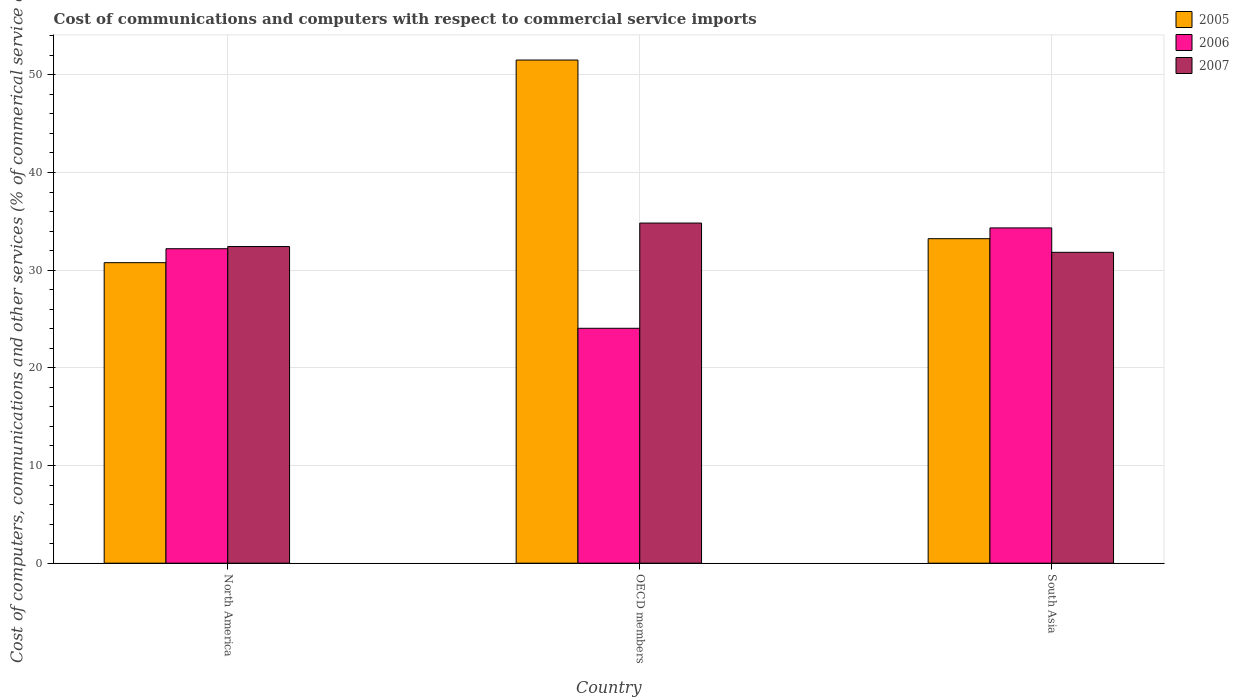How many different coloured bars are there?
Provide a short and direct response. 3. How many groups of bars are there?
Offer a terse response. 3. Are the number of bars per tick equal to the number of legend labels?
Ensure brevity in your answer.  Yes. What is the label of the 3rd group of bars from the left?
Provide a short and direct response. South Asia. What is the cost of communications and computers in 2005 in OECD members?
Your response must be concise. 51.51. Across all countries, what is the maximum cost of communications and computers in 2007?
Offer a terse response. 34.82. Across all countries, what is the minimum cost of communications and computers in 2007?
Offer a terse response. 31.83. What is the total cost of communications and computers in 2007 in the graph?
Provide a short and direct response. 99.07. What is the difference between the cost of communications and computers in 2006 in North America and that in South Asia?
Give a very brief answer. -2.13. What is the difference between the cost of communications and computers in 2007 in OECD members and the cost of communications and computers in 2006 in North America?
Make the answer very short. 2.63. What is the average cost of communications and computers in 2007 per country?
Provide a succinct answer. 33.02. What is the difference between the cost of communications and computers of/in 2005 and cost of communications and computers of/in 2006 in North America?
Give a very brief answer. -1.43. What is the ratio of the cost of communications and computers in 2006 in North America to that in South Asia?
Offer a very short reply. 0.94. Is the cost of communications and computers in 2007 in North America less than that in OECD members?
Offer a terse response. Yes. What is the difference between the highest and the second highest cost of communications and computers in 2005?
Ensure brevity in your answer.  -18.29. What is the difference between the highest and the lowest cost of communications and computers in 2006?
Your answer should be very brief. 10.28. In how many countries, is the cost of communications and computers in 2007 greater than the average cost of communications and computers in 2007 taken over all countries?
Keep it short and to the point. 1. What does the 1st bar from the left in OECD members represents?
Offer a terse response. 2005. Is it the case that in every country, the sum of the cost of communications and computers in 2005 and cost of communications and computers in 2006 is greater than the cost of communications and computers in 2007?
Keep it short and to the point. Yes. Are all the bars in the graph horizontal?
Ensure brevity in your answer.  No. How many countries are there in the graph?
Your response must be concise. 3. What is the difference between two consecutive major ticks on the Y-axis?
Ensure brevity in your answer.  10. Are the values on the major ticks of Y-axis written in scientific E-notation?
Offer a terse response. No. Does the graph contain grids?
Your answer should be compact. Yes. How many legend labels are there?
Offer a terse response. 3. What is the title of the graph?
Your answer should be very brief. Cost of communications and computers with respect to commercial service imports. Does "1975" appear as one of the legend labels in the graph?
Your answer should be very brief. No. What is the label or title of the X-axis?
Your answer should be very brief. Country. What is the label or title of the Y-axis?
Your answer should be very brief. Cost of computers, communications and other services (% of commerical service exports). What is the Cost of computers, communications and other services (% of commerical service exports) in 2005 in North America?
Offer a very short reply. 30.77. What is the Cost of computers, communications and other services (% of commerical service exports) in 2006 in North America?
Ensure brevity in your answer.  32.2. What is the Cost of computers, communications and other services (% of commerical service exports) in 2007 in North America?
Ensure brevity in your answer.  32.42. What is the Cost of computers, communications and other services (% of commerical service exports) of 2005 in OECD members?
Your answer should be very brief. 51.51. What is the Cost of computers, communications and other services (% of commerical service exports) in 2006 in OECD members?
Your answer should be very brief. 24.05. What is the Cost of computers, communications and other services (% of commerical service exports) of 2007 in OECD members?
Keep it short and to the point. 34.82. What is the Cost of computers, communications and other services (% of commerical service exports) in 2005 in South Asia?
Your answer should be compact. 33.22. What is the Cost of computers, communications and other services (% of commerical service exports) in 2006 in South Asia?
Ensure brevity in your answer.  34.33. What is the Cost of computers, communications and other services (% of commerical service exports) in 2007 in South Asia?
Your answer should be compact. 31.83. Across all countries, what is the maximum Cost of computers, communications and other services (% of commerical service exports) in 2005?
Offer a terse response. 51.51. Across all countries, what is the maximum Cost of computers, communications and other services (% of commerical service exports) of 2006?
Your answer should be compact. 34.33. Across all countries, what is the maximum Cost of computers, communications and other services (% of commerical service exports) in 2007?
Provide a short and direct response. 34.82. Across all countries, what is the minimum Cost of computers, communications and other services (% of commerical service exports) in 2005?
Keep it short and to the point. 30.77. Across all countries, what is the minimum Cost of computers, communications and other services (% of commerical service exports) in 2006?
Make the answer very short. 24.05. Across all countries, what is the minimum Cost of computers, communications and other services (% of commerical service exports) of 2007?
Your answer should be very brief. 31.83. What is the total Cost of computers, communications and other services (% of commerical service exports) in 2005 in the graph?
Provide a short and direct response. 115.5. What is the total Cost of computers, communications and other services (% of commerical service exports) in 2006 in the graph?
Your answer should be very brief. 90.57. What is the total Cost of computers, communications and other services (% of commerical service exports) in 2007 in the graph?
Your response must be concise. 99.07. What is the difference between the Cost of computers, communications and other services (% of commerical service exports) of 2005 in North America and that in OECD members?
Make the answer very short. -20.75. What is the difference between the Cost of computers, communications and other services (% of commerical service exports) of 2006 in North America and that in OECD members?
Give a very brief answer. 8.15. What is the difference between the Cost of computers, communications and other services (% of commerical service exports) of 2007 in North America and that in OECD members?
Your answer should be compact. -2.4. What is the difference between the Cost of computers, communications and other services (% of commerical service exports) of 2005 in North America and that in South Asia?
Your answer should be very brief. -2.46. What is the difference between the Cost of computers, communications and other services (% of commerical service exports) of 2006 in North America and that in South Asia?
Offer a terse response. -2.13. What is the difference between the Cost of computers, communications and other services (% of commerical service exports) of 2007 in North America and that in South Asia?
Give a very brief answer. 0.59. What is the difference between the Cost of computers, communications and other services (% of commerical service exports) of 2005 in OECD members and that in South Asia?
Provide a succinct answer. 18.29. What is the difference between the Cost of computers, communications and other services (% of commerical service exports) in 2006 in OECD members and that in South Asia?
Make the answer very short. -10.28. What is the difference between the Cost of computers, communications and other services (% of commerical service exports) in 2007 in OECD members and that in South Asia?
Keep it short and to the point. 3. What is the difference between the Cost of computers, communications and other services (% of commerical service exports) in 2005 in North America and the Cost of computers, communications and other services (% of commerical service exports) in 2006 in OECD members?
Offer a terse response. 6.72. What is the difference between the Cost of computers, communications and other services (% of commerical service exports) of 2005 in North America and the Cost of computers, communications and other services (% of commerical service exports) of 2007 in OECD members?
Make the answer very short. -4.06. What is the difference between the Cost of computers, communications and other services (% of commerical service exports) in 2006 in North America and the Cost of computers, communications and other services (% of commerical service exports) in 2007 in OECD members?
Keep it short and to the point. -2.63. What is the difference between the Cost of computers, communications and other services (% of commerical service exports) in 2005 in North America and the Cost of computers, communications and other services (% of commerical service exports) in 2006 in South Asia?
Your answer should be very brief. -3.56. What is the difference between the Cost of computers, communications and other services (% of commerical service exports) of 2005 in North America and the Cost of computers, communications and other services (% of commerical service exports) of 2007 in South Asia?
Ensure brevity in your answer.  -1.06. What is the difference between the Cost of computers, communications and other services (% of commerical service exports) of 2006 in North America and the Cost of computers, communications and other services (% of commerical service exports) of 2007 in South Asia?
Give a very brief answer. 0.37. What is the difference between the Cost of computers, communications and other services (% of commerical service exports) in 2005 in OECD members and the Cost of computers, communications and other services (% of commerical service exports) in 2006 in South Asia?
Keep it short and to the point. 17.19. What is the difference between the Cost of computers, communications and other services (% of commerical service exports) of 2005 in OECD members and the Cost of computers, communications and other services (% of commerical service exports) of 2007 in South Asia?
Offer a very short reply. 19.69. What is the difference between the Cost of computers, communications and other services (% of commerical service exports) in 2006 in OECD members and the Cost of computers, communications and other services (% of commerical service exports) in 2007 in South Asia?
Provide a succinct answer. -7.78. What is the average Cost of computers, communications and other services (% of commerical service exports) of 2005 per country?
Keep it short and to the point. 38.5. What is the average Cost of computers, communications and other services (% of commerical service exports) in 2006 per country?
Provide a short and direct response. 30.19. What is the average Cost of computers, communications and other services (% of commerical service exports) of 2007 per country?
Ensure brevity in your answer.  33.02. What is the difference between the Cost of computers, communications and other services (% of commerical service exports) of 2005 and Cost of computers, communications and other services (% of commerical service exports) of 2006 in North America?
Your response must be concise. -1.43. What is the difference between the Cost of computers, communications and other services (% of commerical service exports) of 2005 and Cost of computers, communications and other services (% of commerical service exports) of 2007 in North America?
Provide a succinct answer. -1.65. What is the difference between the Cost of computers, communications and other services (% of commerical service exports) in 2006 and Cost of computers, communications and other services (% of commerical service exports) in 2007 in North America?
Keep it short and to the point. -0.22. What is the difference between the Cost of computers, communications and other services (% of commerical service exports) of 2005 and Cost of computers, communications and other services (% of commerical service exports) of 2006 in OECD members?
Make the answer very short. 27.46. What is the difference between the Cost of computers, communications and other services (% of commerical service exports) of 2005 and Cost of computers, communications and other services (% of commerical service exports) of 2007 in OECD members?
Keep it short and to the point. 16.69. What is the difference between the Cost of computers, communications and other services (% of commerical service exports) in 2006 and Cost of computers, communications and other services (% of commerical service exports) in 2007 in OECD members?
Provide a short and direct response. -10.77. What is the difference between the Cost of computers, communications and other services (% of commerical service exports) of 2005 and Cost of computers, communications and other services (% of commerical service exports) of 2006 in South Asia?
Offer a terse response. -1.1. What is the difference between the Cost of computers, communications and other services (% of commerical service exports) in 2005 and Cost of computers, communications and other services (% of commerical service exports) in 2007 in South Asia?
Your answer should be compact. 1.39. What is the difference between the Cost of computers, communications and other services (% of commerical service exports) of 2006 and Cost of computers, communications and other services (% of commerical service exports) of 2007 in South Asia?
Offer a terse response. 2.5. What is the ratio of the Cost of computers, communications and other services (% of commerical service exports) of 2005 in North America to that in OECD members?
Give a very brief answer. 0.6. What is the ratio of the Cost of computers, communications and other services (% of commerical service exports) in 2006 in North America to that in OECD members?
Your response must be concise. 1.34. What is the ratio of the Cost of computers, communications and other services (% of commerical service exports) in 2007 in North America to that in OECD members?
Your answer should be compact. 0.93. What is the ratio of the Cost of computers, communications and other services (% of commerical service exports) in 2005 in North America to that in South Asia?
Make the answer very short. 0.93. What is the ratio of the Cost of computers, communications and other services (% of commerical service exports) of 2006 in North America to that in South Asia?
Give a very brief answer. 0.94. What is the ratio of the Cost of computers, communications and other services (% of commerical service exports) of 2007 in North America to that in South Asia?
Offer a very short reply. 1.02. What is the ratio of the Cost of computers, communications and other services (% of commerical service exports) of 2005 in OECD members to that in South Asia?
Offer a very short reply. 1.55. What is the ratio of the Cost of computers, communications and other services (% of commerical service exports) in 2006 in OECD members to that in South Asia?
Offer a terse response. 0.7. What is the ratio of the Cost of computers, communications and other services (% of commerical service exports) of 2007 in OECD members to that in South Asia?
Ensure brevity in your answer.  1.09. What is the difference between the highest and the second highest Cost of computers, communications and other services (% of commerical service exports) of 2005?
Offer a very short reply. 18.29. What is the difference between the highest and the second highest Cost of computers, communications and other services (% of commerical service exports) in 2006?
Offer a very short reply. 2.13. What is the difference between the highest and the second highest Cost of computers, communications and other services (% of commerical service exports) in 2007?
Provide a short and direct response. 2.4. What is the difference between the highest and the lowest Cost of computers, communications and other services (% of commerical service exports) of 2005?
Your response must be concise. 20.75. What is the difference between the highest and the lowest Cost of computers, communications and other services (% of commerical service exports) of 2006?
Provide a short and direct response. 10.28. What is the difference between the highest and the lowest Cost of computers, communications and other services (% of commerical service exports) of 2007?
Ensure brevity in your answer.  3. 